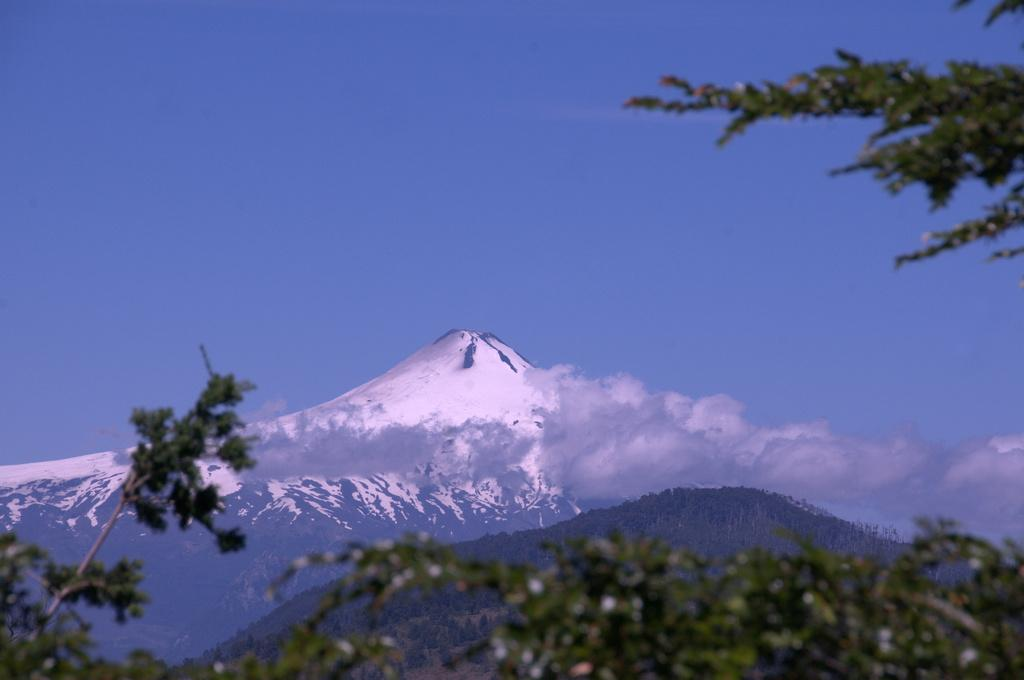What type of natural features can be seen in the image? There are trees, hills, and a mountain covered with snow in the image. Can you describe the sky in the image? The sky is clear and visible in the image. What is the tax rate for the police department in the image? There is no information about tax rates or a police department in the image, as it primarily features natural landscapes. 